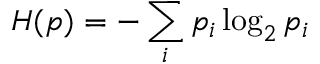<formula> <loc_0><loc_0><loc_500><loc_500>H ( p ) = - \sum _ { i } p _ { i } \log _ { 2 } p _ { i }</formula> 